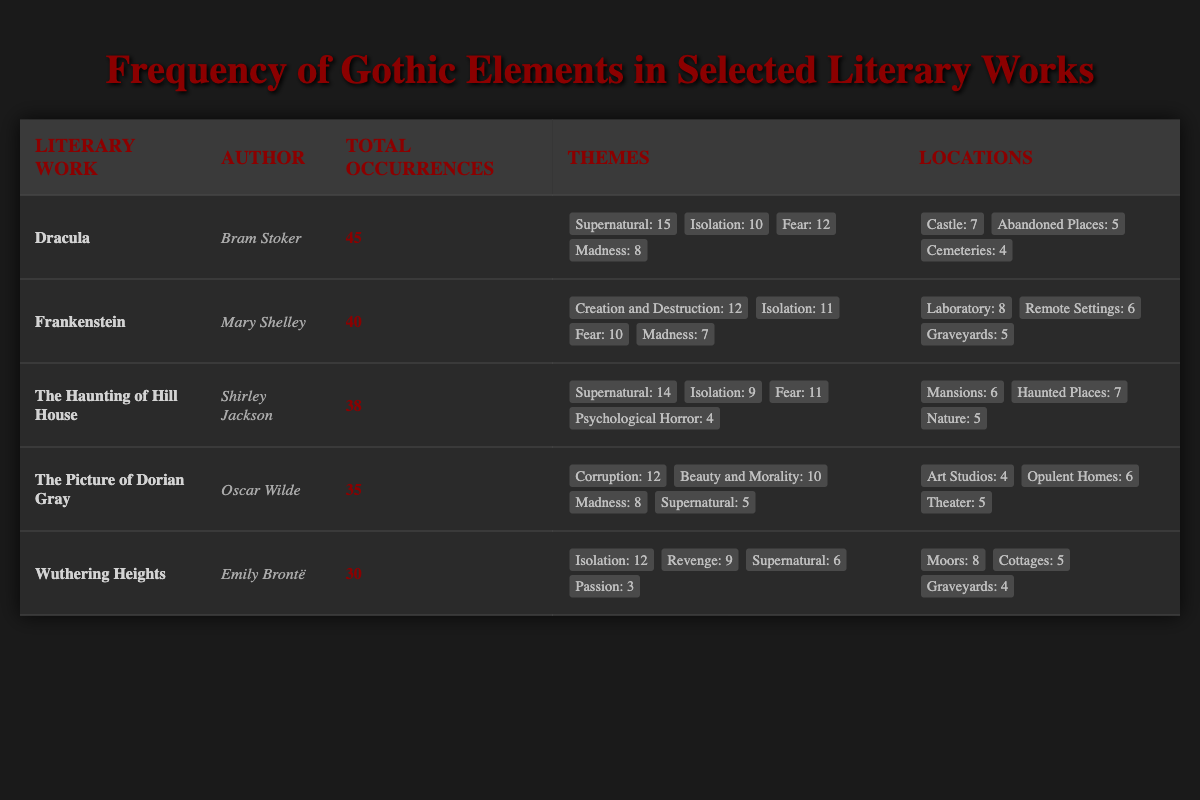What is the total number of occurrences of Gothic elements in "Dracula"? The table lists "Dracula" under Literary Work with a corresponding value for Total Occurrences of 45.
Answer: 45 Which author has the highest total occurrences of Gothic elements in their work? The table indicates that "Dracula" by Bram Stoker has the highest total occurrences with 45.
Answer: Bram Stoker How many occurrences of the theme of 'Isolation' are there in "Frankenstein"? In the row for "Frankenstein," the value under Themes for 'Isolation' is 11.
Answer: 11 What is the sum of occurrences for the themes of 'Madness' in all listed works? The table lists the following values for 'Madness': 8 in "Dracula," 7 in "Frankenstein," 4 in "The Haunting of Hill House," 8 in "The Picture of Dorian Gray," and 3 in "Wuthering Heights." Summing these gives 8 + 7 + 4 + 8 + 3 = 30.
Answer: 30 Are there more occurrences of 'Fear' in "The Haunting of Hill House" than in "The Picture of Dorian Gray"? In "The Haunting of Hill House," the occurrences of 'Fear' is 11. In "The Picture of Dorian Gray," the occurrences of 'Fear' is 8. Since 11 is greater than 8, the statement is true.
Answer: Yes What is the average number of occurrences for the theme 'Supernatural' across all listed works? The occurrences for 'Supernatural' are: 15 in "Dracula," 0 in "Frankenstein," 14 in "The Haunting of Hill House," 5 in "The Picture of Dorian Gray," and 6 in "Wuthering Heights." The total is 15 + 0 + 14 + 5 + 6 = 40. There are 5 data points, so the average is 40/5 = 8.
Answer: 8 In how many works does the location 'Castle' appear, and which is the work? Only "Dracula" contains the location 'Castle' with a value of 7 occurrences. Thus, it appears in 1 work, namely "Dracula."
Answer: 1 work, "Dracula" Which work features the most locations with occurrences noted? The locations for each work show that "Dracula" lists 3 different locations, "Frankenstein" also has 3, "The Haunting of Hill House" has 3, "The Picture of Dorian Gray" has 3, and "Wuthering Heights" has 3. Since all have 3, none has more than the others.
Answer: None, all feature 3 locations How does the frequency of the theme 'Corruption' compare to that of 'Revenge' across the listed works? "The Picture of Dorian Gray" has 12 occurrences of 'Corruption' and "Wuthering Heights" has 9 occurrences of 'Revenge.' Since 12 is greater than 9, 'Corruption' is more frequent.
Answer: 'Corruption' is more frequent 